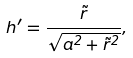Convert formula to latex. <formula><loc_0><loc_0><loc_500><loc_500>h ^ { \prime } = \frac { \tilde { r } } { \sqrt { a ^ { 2 } + \tilde { r } ^ { 2 } } } ,</formula> 